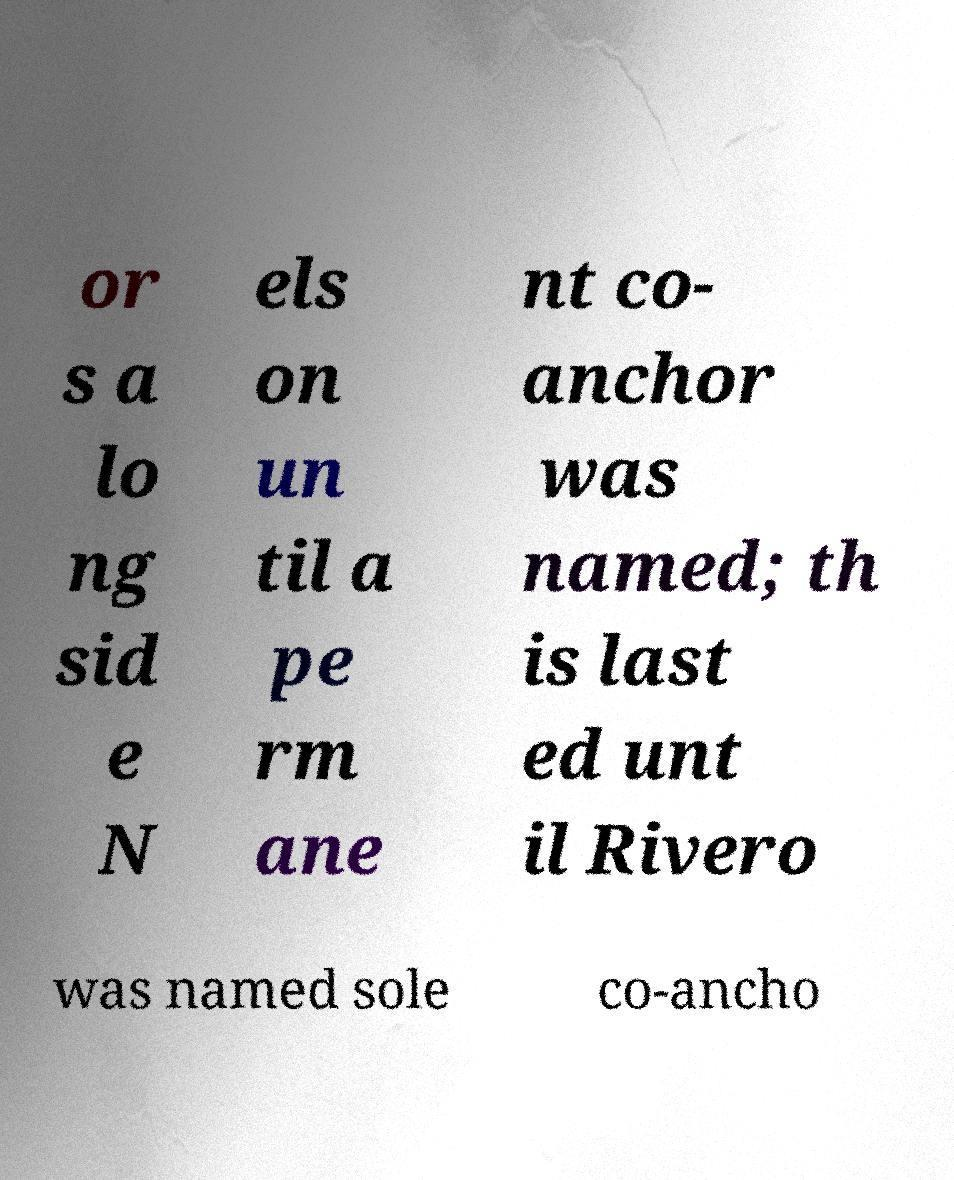Can you read and provide the text displayed in the image?This photo seems to have some interesting text. Can you extract and type it out for me? or s a lo ng sid e N els on un til a pe rm ane nt co- anchor was named; th is last ed unt il Rivero was named sole co-ancho 